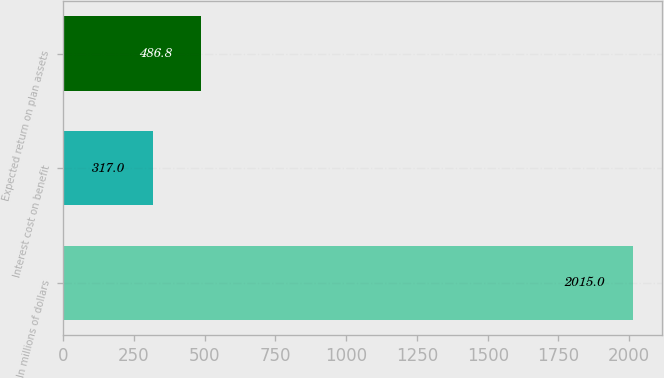<chart> <loc_0><loc_0><loc_500><loc_500><bar_chart><fcel>In millions of dollars<fcel>Interest cost on benefit<fcel>Expected return on plan assets<nl><fcel>2015<fcel>317<fcel>486.8<nl></chart> 